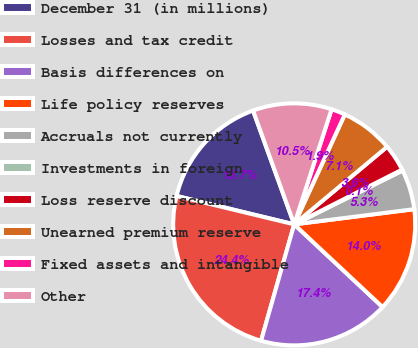Convert chart. <chart><loc_0><loc_0><loc_500><loc_500><pie_chart><fcel>December 31 (in millions)<fcel>Losses and tax credit<fcel>Basis differences on<fcel>Life policy reserves<fcel>Accruals not currently<fcel>Investments in foreign<fcel>Loss reserve discount<fcel>Unearned premium reserve<fcel>Fixed assets and intangible<fcel>Other<nl><fcel>15.71%<fcel>24.36%<fcel>17.44%<fcel>13.98%<fcel>5.33%<fcel>0.14%<fcel>3.6%<fcel>7.06%<fcel>1.87%<fcel>10.52%<nl></chart> 